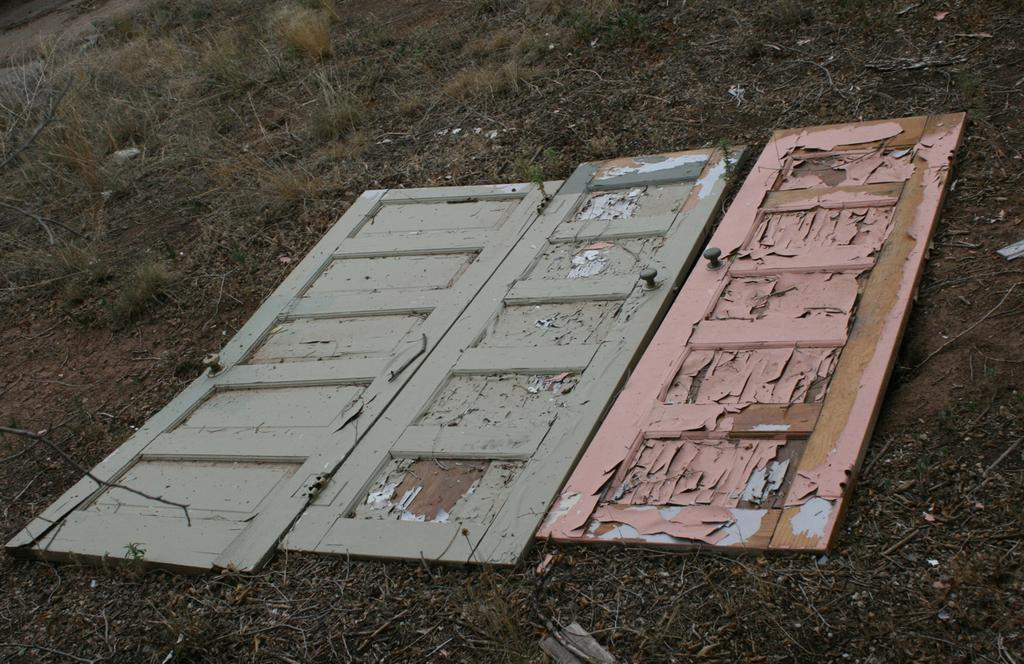What type of doors are present in the image? There are wooden doors on the ground in the image. What can be seen in the background of the image? There is grass visible in the background of the image. What type of ship is visible in the image? There is no ship present in the image; it features wooden doors on the ground and grass in the background. Who is sitting on the throne in the image? There is no throne present in the image; it only features wooden doors and grass. 